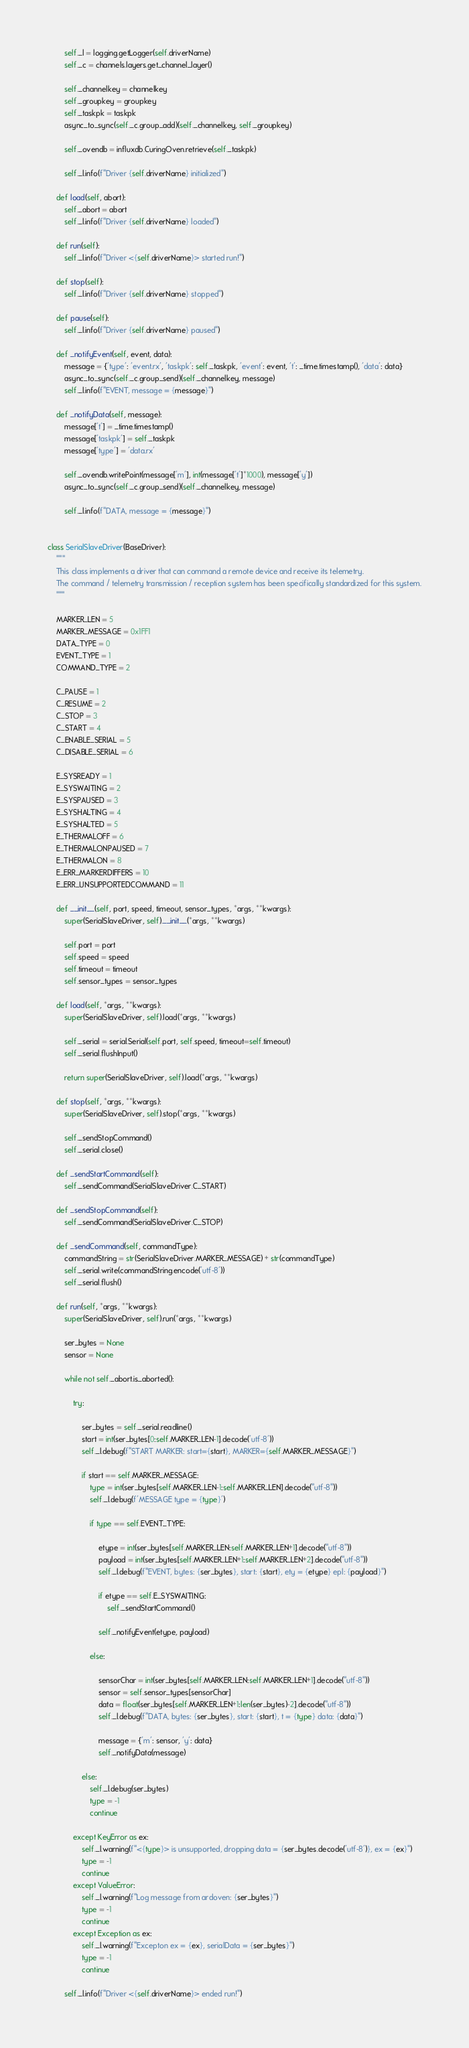<code> <loc_0><loc_0><loc_500><loc_500><_Python_>        self._l = logging.getLogger(self.driverName)
        self._c = channels.layers.get_channel_layer()

        self._channelkey = channelkey
        self._groupkey = groupkey
        self._taskpk = taskpk
        async_to_sync(self._c.group_add)(self._channelkey, self._groupkey)

        self._ovendb = influxdb.CuringOven.retrieve(self._taskpk)

        self._l.info(f"Driver {self.driverName} initialized")

    def load(self, abort):
        self._abort = abort
        self._l.info(f"Driver {self.driverName} loaded")

    def run(self):
        self._l.info(f"Driver <{self.driverName}> started run!")

    def stop(self):
        self._l.info(f"Driver {self.driverName} stopped")

    def pause(self):
        self._l.info(f"Driver {self.driverName} paused")

    def _notifyEvent(self, event, data):
        message = {'type': 'event.rx', 'taskpk': self._taskpk, 'event': event, 't': _time.timestamp(), 'data': data}
        async_to_sync(self._c.group_send)(self._channelkey, message)
        self._l.info(f"EVENT, message = {message}")

    def _notifyData(self, message):
        message['t'] = _time.timestamp()
        message['taskpk'] = self._taskpk
        message['type'] = 'data.rx'

        self._ovendb.writePoint(message['m'], int(message['t']*1000), message['y'])
        async_to_sync(self._c.group_send)(self._channelkey, message)

        self._l.info(f"DATA, message = {message}")


class SerialSlaveDriver(BaseDriver):
    """
    This class implements a driver that can command a remote device and receive its telemetry.
    The command / telemetry transmission / reception system has been specifically standardized for this system.
    """

    MARKER_LEN = 5
    MARKER_MESSAGE = 0x1FF1
    DATA_TYPE = 0
    EVENT_TYPE = 1
    COMMAND_TYPE = 2

    C_PAUSE = 1
    C_RESUME = 2
    C_STOP = 3
    C_START = 4
    C_ENABLE_SERIAL = 5
    C_DISABLE_SERIAL = 6

    E_SYSREADY = 1
    E_SYSWAITING = 2
    E_SYSPAUSED = 3
    E_SYSHALTING = 4
    E_SYSHALTED = 5
    E_THERMALOFF = 6
    E_THERMALONPAUSED = 7
    E_THERMALON = 8
    E_ERR_MARKERDIFFERS = 10
    E_ERR_UNSUPPORTEDCOMMAND = 11

    def __init__(self, port, speed, timeout, sensor_types, *args, **kwargs):
        super(SerialSlaveDriver, self).__init__(*args, **kwargs)

        self.port = port
        self.speed = speed
        self.timeout = timeout
        self.sensor_types = sensor_types

    def load(self, *args, **kwargs):
        super(SerialSlaveDriver, self).load(*args, **kwargs)

        self._serial = serial.Serial(self.port, self.speed, timeout=self.timeout)
        self._serial.flushInput()

        return super(SerialSlaveDriver, self).load(*args, **kwargs)

    def stop(self, *args, **kwargs):
        super(SerialSlaveDriver, self).stop(*args, **kwargs)

        self._sendStopCommand()
        self._serial.close()

    def _sendStartCommand(self):
        self._sendCommand(SerialSlaveDriver.C_START)

    def _sendStopCommand(self):
        self._sendCommand(SerialSlaveDriver.C_STOP)

    def _sendCommand(self, commandType):
        commandString = str(SerialSlaveDriver.MARKER_MESSAGE) + str(commandType)
        self._serial.write(commandString.encode('utf-8'))
        self._serial.flush()

    def run(self, *args, **kwargs):
        super(SerialSlaveDriver, self).run(*args, **kwargs)

        ser_bytes = None
        sensor = None

        while not self._abort.is_aborted():

            try:

                ser_bytes = self._serial.readline()
                start = int(ser_bytes[0:self.MARKER_LEN-1].decode('utf-8'))
                self._l.debug(f"START MARKER: start={start}, MARKER={self.MARKER_MESSAGE}")

                if start == self.MARKER_MESSAGE:
                    type = int(ser_bytes[self.MARKER_LEN-1:self.MARKER_LEN].decode("utf-8"))
                    self._l.debug(f'MESSAGE type = {type}')

                    if type == self.EVENT_TYPE:

                        etype = int(ser_bytes[self.MARKER_LEN:self.MARKER_LEN+1].decode("utf-8"))
                        payload = int(ser_bytes[self.MARKER_LEN+1:self.MARKER_LEN+2].decode("utf-8"))
                        self._l.debug(f"EVENT, bytes: {ser_bytes}, start: {start}, ety = {etype} epl: {payload}")

                        if etype == self.E_SYSWAITING:
                            self._sendStartCommand()

                        self._notifyEvent(etype, payload)

                    else:

                        sensorChar = int(ser_bytes[self.MARKER_LEN:self.MARKER_LEN+1].decode("utf-8"))
                        sensor = self.sensor_types[sensorChar]
                        data = float(ser_bytes[self.MARKER_LEN+1:len(ser_bytes)-2].decode("utf-8"))
                        self._l.debug(f"DATA, bytes: {ser_bytes}, start: {start}, t = {type} data: {data}")

                        message = {'m': sensor, 'y': data}
                        self._notifyData(message)

                else:
                    self._l.debug(ser_bytes)
                    type = -1
                    continue

            except KeyError as ex:
                self._l.warning(f"<{type}> is unsupported, dropping data = {ser_bytes.decode('utf-8')}, ex = {ex}")
                type = -1
                continue
            except ValueError:
                self._l.warning(f"Log message from ardoven: {ser_bytes}")
                type = -1
                continue
            except Exception as ex:
                self._l.warning(f"Excepton ex = {ex}, serialData = {ser_bytes}")
                type = -1
                continue

        self._l.info(f"Driver <{self.driverName}> ended run!")
</code> 